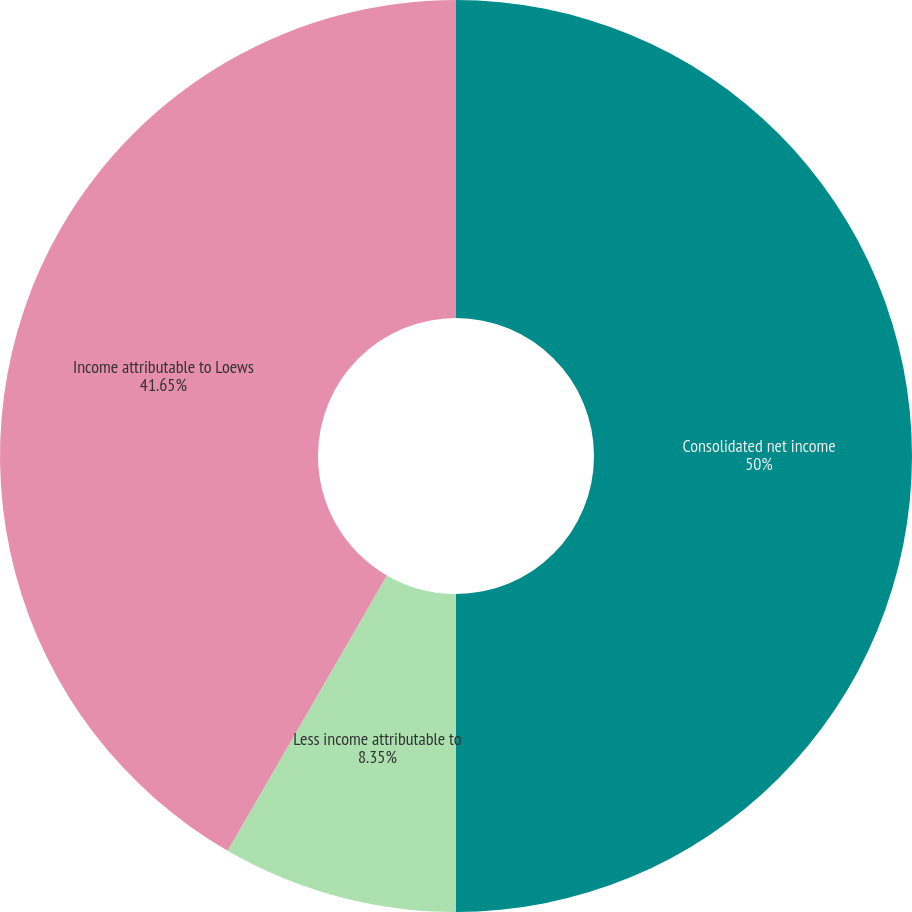Convert chart. <chart><loc_0><loc_0><loc_500><loc_500><pie_chart><fcel>Consolidated net income<fcel>Less income attributable to<fcel>Income attributable to Loews<nl><fcel>50.0%<fcel>8.35%<fcel>41.65%<nl></chart> 